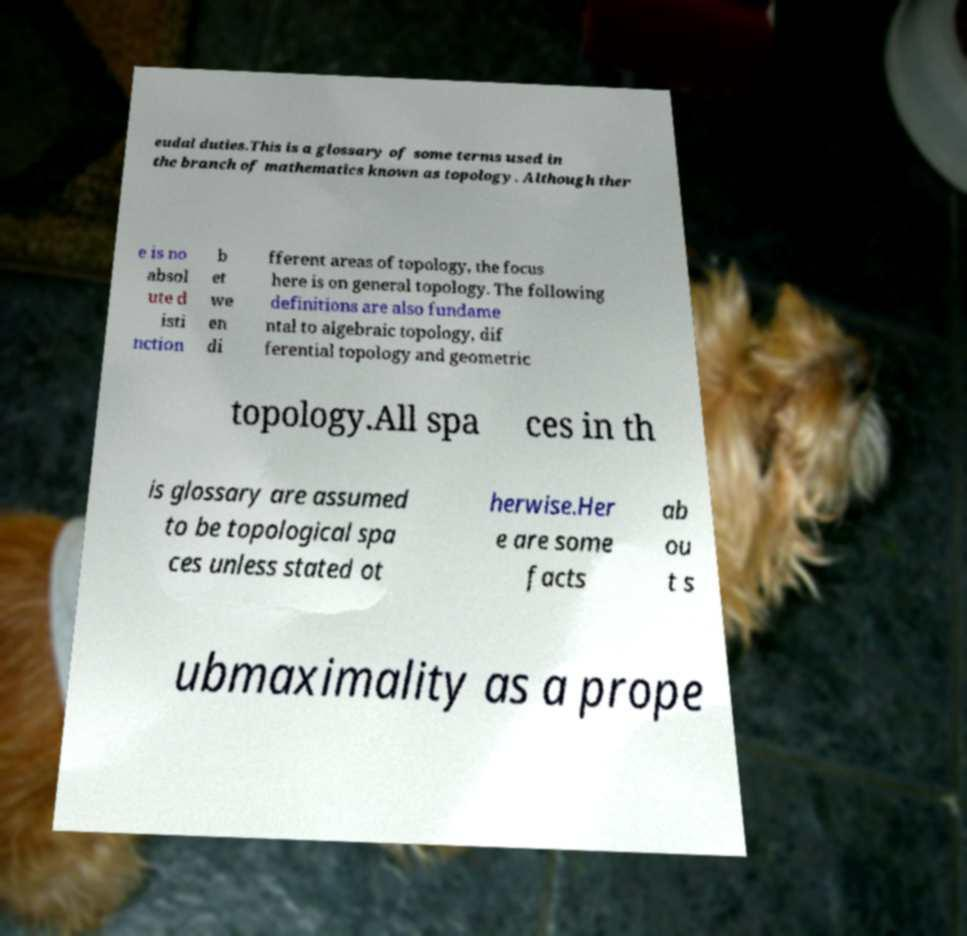Please identify and transcribe the text found in this image. eudal duties.This is a glossary of some terms used in the branch of mathematics known as topology. Although ther e is no absol ute d isti nction b et we en di fferent areas of topology, the focus here is on general topology. The following definitions are also fundame ntal to algebraic topology, dif ferential topology and geometric topology.All spa ces in th is glossary are assumed to be topological spa ces unless stated ot herwise.Her e are some facts ab ou t s ubmaximality as a prope 